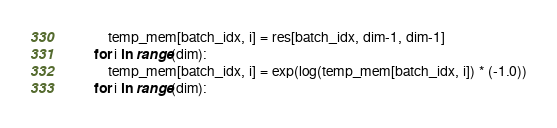<code> <loc_0><loc_0><loc_500><loc_500><_Python_>            temp_mem[batch_idx, i] = res[batch_idx, dim-1, dim-1]
        for i in range(dim):
            temp_mem[batch_idx, i] = exp(log(temp_mem[batch_idx, i]) * (-1.0))
        for i in range(dim):</code> 